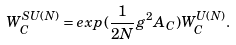<formula> <loc_0><loc_0><loc_500><loc_500>W _ { C } ^ { S U ( N ) } = e x p ( \frac { 1 } { 2 N } g ^ { 2 } A _ { C } ) W _ { C } ^ { U ( N ) } .</formula> 